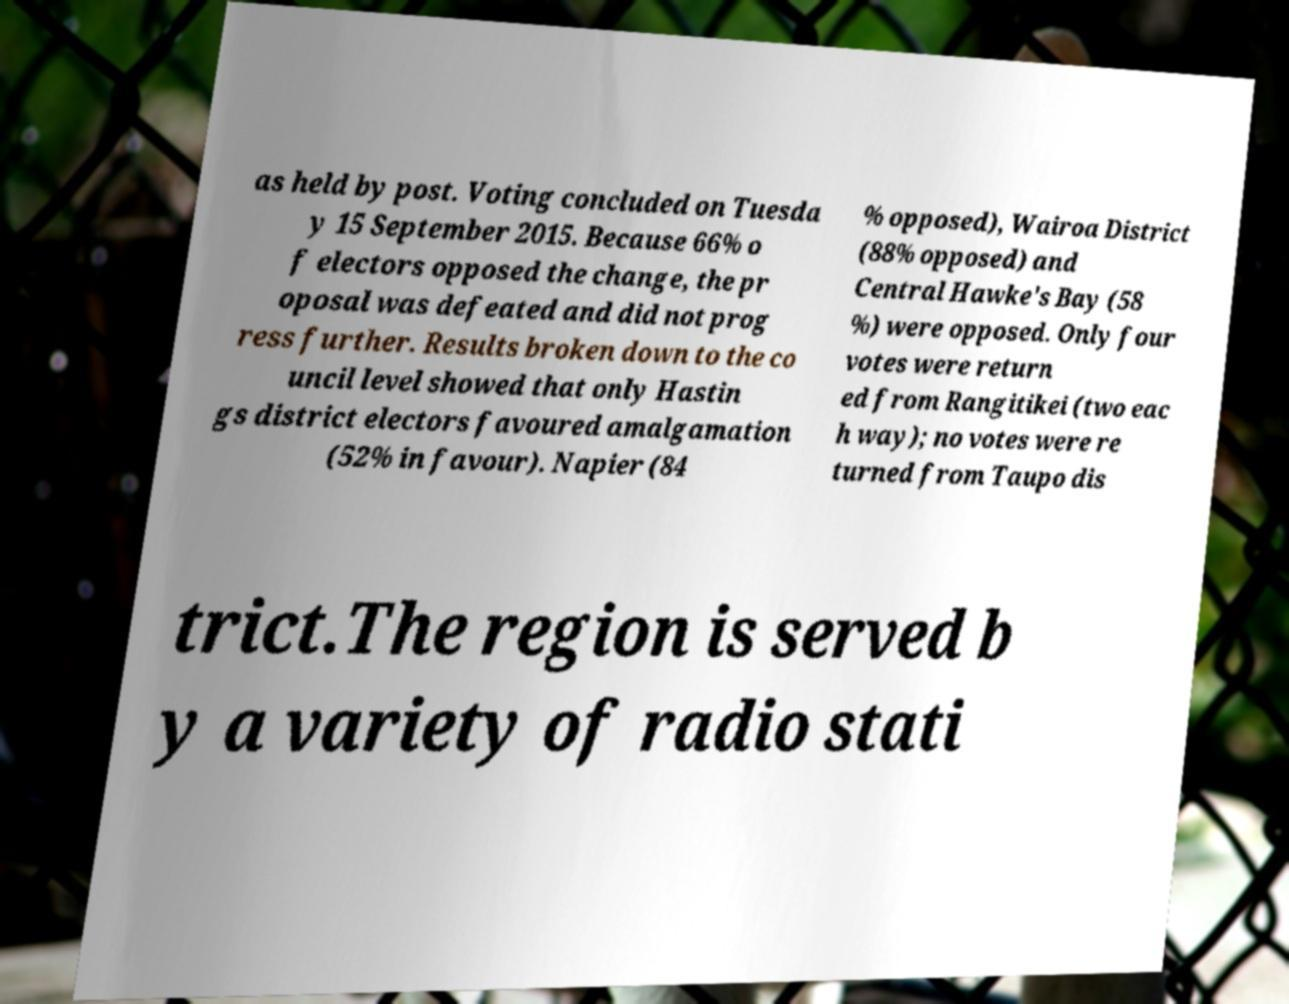What messages or text are displayed in this image? I need them in a readable, typed format. as held by post. Voting concluded on Tuesda y 15 September 2015. Because 66% o f electors opposed the change, the pr oposal was defeated and did not prog ress further. Results broken down to the co uncil level showed that only Hastin gs district electors favoured amalgamation (52% in favour). Napier (84 % opposed), Wairoa District (88% opposed) and Central Hawke's Bay (58 %) were opposed. Only four votes were return ed from Rangitikei (two eac h way); no votes were re turned from Taupo dis trict.The region is served b y a variety of radio stati 